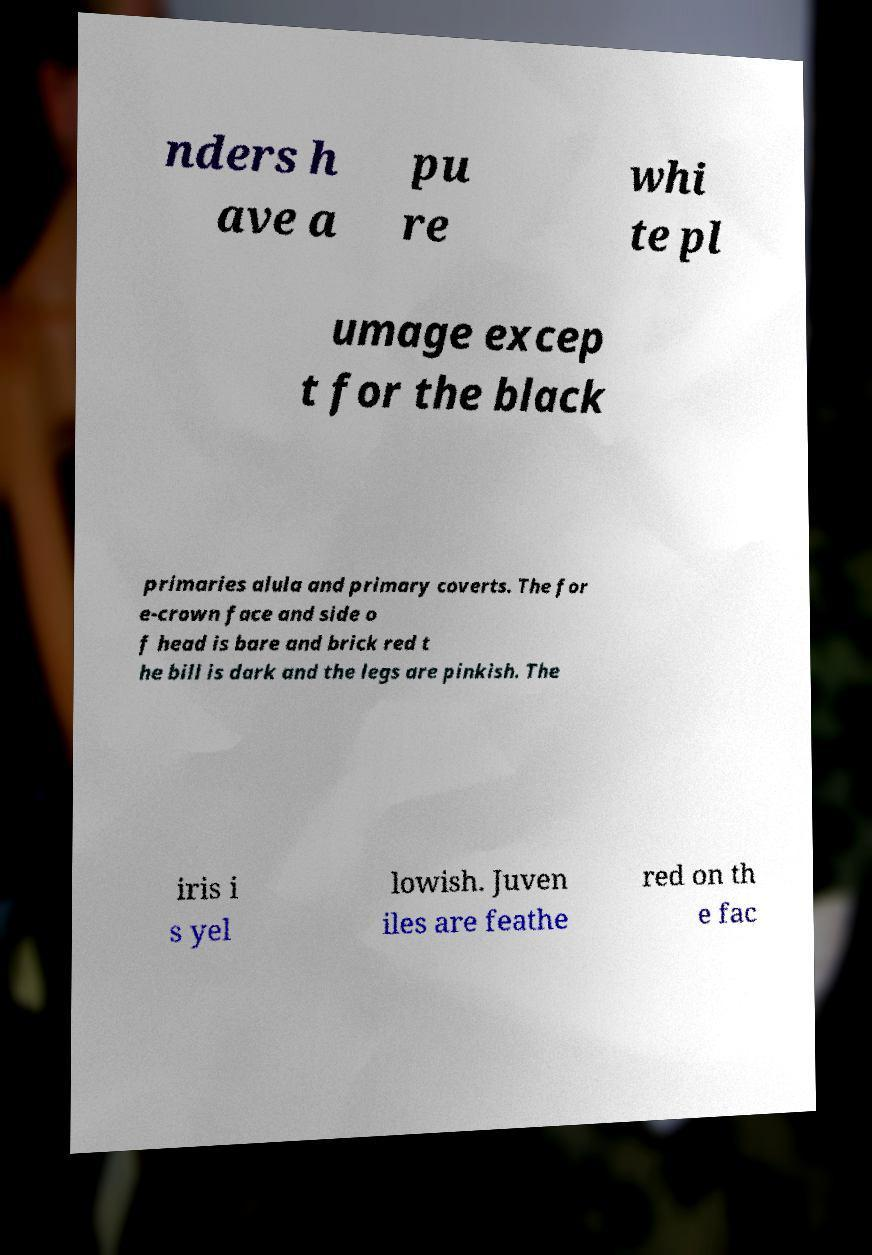Please identify and transcribe the text found in this image. nders h ave a pu re whi te pl umage excep t for the black primaries alula and primary coverts. The for e-crown face and side o f head is bare and brick red t he bill is dark and the legs are pinkish. The iris i s yel lowish. Juven iles are feathe red on th e fac 